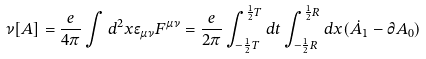Convert formula to latex. <formula><loc_0><loc_0><loc_500><loc_500>\nu [ A ] = \frac { e } { 4 \pi } \int d ^ { 2 } x \epsilon _ { \mu \nu } F ^ { \mu \nu } = \frac { e } { 2 \pi } \int _ { - \frac { 1 } { 2 } T } ^ { \frac { 1 } { 2 } T } d t \int _ { - \frac { 1 } { 2 } R } ^ { \frac { 1 } { 2 } R } d x ( \dot { A } _ { 1 } - \partial A _ { 0 } )</formula> 